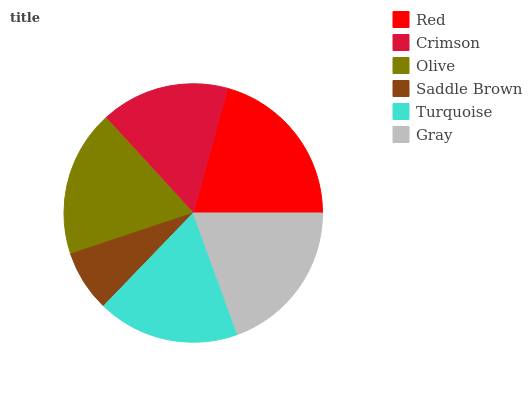Is Saddle Brown the minimum?
Answer yes or no. Yes. Is Red the maximum?
Answer yes or no. Yes. Is Crimson the minimum?
Answer yes or no. No. Is Crimson the maximum?
Answer yes or no. No. Is Red greater than Crimson?
Answer yes or no. Yes. Is Crimson less than Red?
Answer yes or no. Yes. Is Crimson greater than Red?
Answer yes or no. No. Is Red less than Crimson?
Answer yes or no. No. Is Olive the high median?
Answer yes or no. Yes. Is Turquoise the low median?
Answer yes or no. Yes. Is Turquoise the high median?
Answer yes or no. No. Is Crimson the low median?
Answer yes or no. No. 